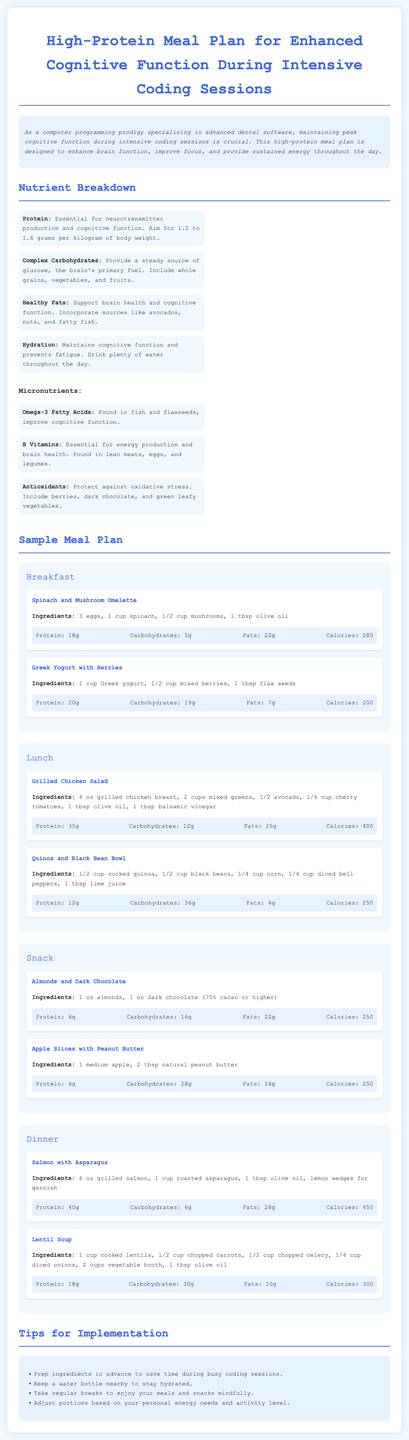what is the protein content in the Spinach and Mushroom Omelette? The protein content is mentioned in the section describing the meal, which states it contains 18 grams of protein.
Answer: 18g how many grams of carbohydrates are in the Greek Yogurt with Berries? The carbohydrates in this meal are specifically listed as 19 grams in the nutrient content section.
Answer: 19g how many ounces of grilled chicken breast are in the Grilled Chicken Salad? The meal description indicates that the salad contains 4 ounces of grilled chicken breast.
Answer: 4 oz what is the calorie count for the Salmon with Asparagus? The calorie count is detailed in the nutrient content, which is provided as 450 calories for this meal.
Answer: 450 which micronutrient is found in fish and flaxseeds that improves cognitive function? The document identifies Omega-3 Fatty Acids as the micronutrient that improves cognitive function and is found in fish and flaxseeds.
Answer: Omega-3 Fatty Acids what should you keep nearby to stay hydrated during coding? The tips section suggests keeping a water bottle nearby for hydration.
Answer: Water bottle how should meal portions be adjusted according to the tips? The tips recommend adjusting portions based on personal energy needs and activity level.
Answer: Personal energy needs what main meal features 6 oz of grilled salmon? The document specifically highlights that the Salmon with Asparagus meal features 6 ounces of grilled salmon.
Answer: Salmon with Asparagus what ingredient is included in the Almonds and Dark Chocolate snack? The snack combines almonds and dark chocolate, both of which are listed in the ingredient section.
Answer: Almonds and Dark Chocolate 